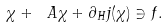<formula> <loc_0><loc_0><loc_500><loc_500>\chi + \ A \chi + \partial _ { H } j ( \chi ) \ni f .</formula> 